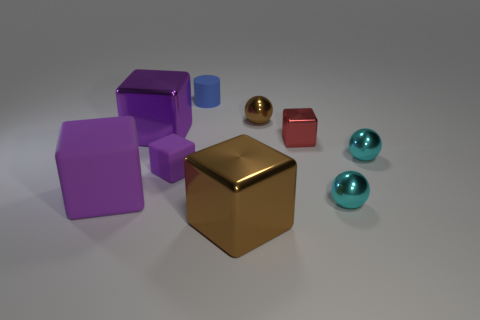How many tiny things are either gray shiny things or matte things?
Ensure brevity in your answer.  2. Is the number of red metal blocks greater than the number of big gray rubber cylinders?
Offer a very short reply. Yes. What is the size of the brown cube that is made of the same material as the brown ball?
Offer a very short reply. Large. Do the purple object on the left side of the purple shiny object and the cube behind the small metallic cube have the same size?
Ensure brevity in your answer.  Yes. What number of objects are either objects that are on the left side of the tiny brown metal thing or shiny things?
Your response must be concise. 9. Are there fewer purple blocks than brown shiny cubes?
Provide a short and direct response. No. The brown shiny thing behind the big shiny object behind the brown thing in front of the tiny brown shiny ball is what shape?
Make the answer very short. Sphere. What is the shape of the rubber object that is the same color as the small rubber cube?
Your response must be concise. Cube. Are there any small gray metallic cylinders?
Offer a terse response. No. There is a brown ball; does it have the same size as the cyan sphere that is behind the tiny purple cube?
Ensure brevity in your answer.  Yes. 